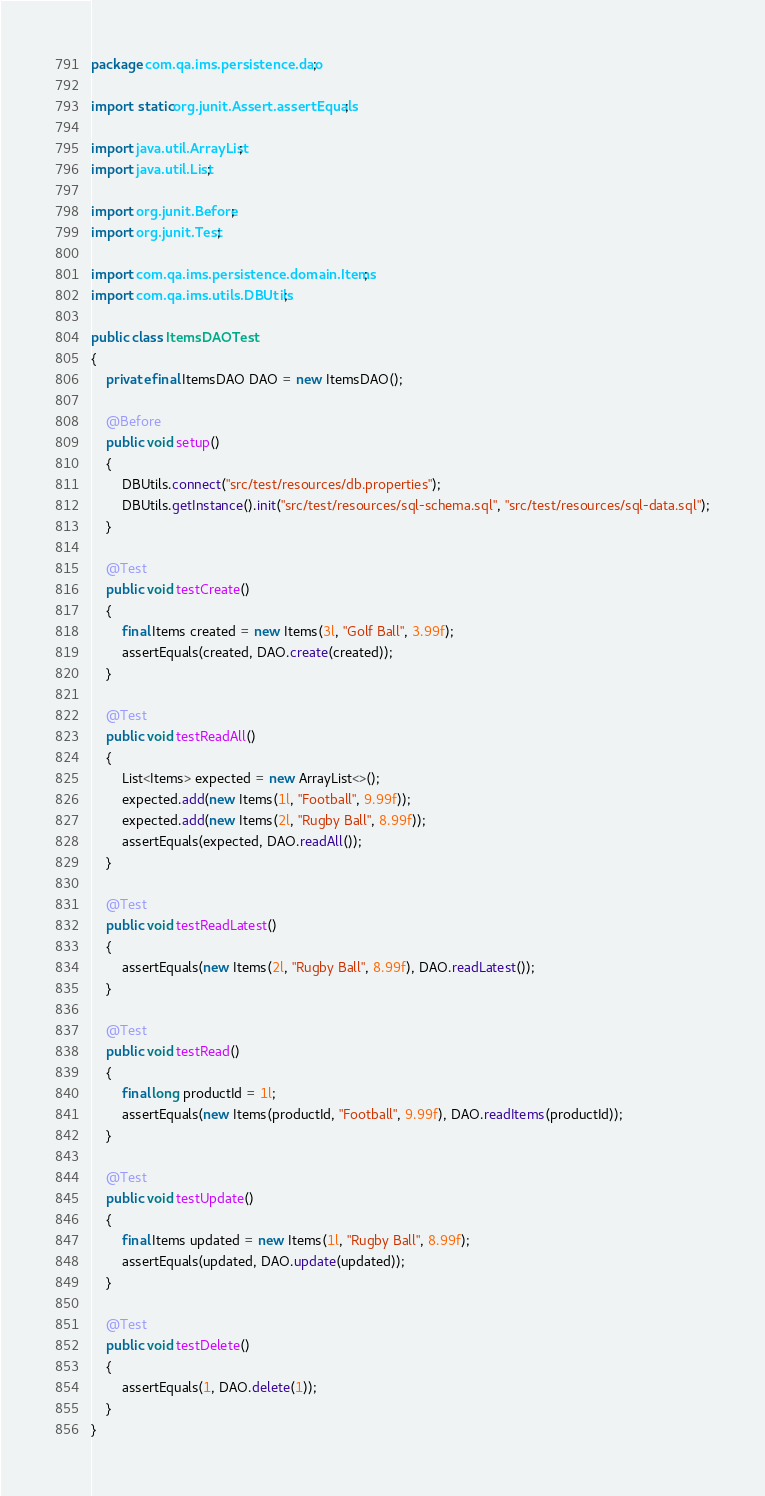<code> <loc_0><loc_0><loc_500><loc_500><_Java_>package com.qa.ims.persistence.dao;

import static org.junit.Assert.assertEquals;

import java.util.ArrayList;
import java.util.List;

import org.junit.Before;
import org.junit.Test;

import com.qa.ims.persistence.domain.Items;
import com.qa.ims.utils.DBUtils;

public class ItemsDAOTest
{
	private final ItemsDAO DAO = new ItemsDAO();

	@Before
	public void setup() 
	{
		DBUtils.connect("src/test/resources/db.properties");
		DBUtils.getInstance().init("src/test/resources/sql-schema.sql", "src/test/resources/sql-data.sql");
	}

	@Test
	public void testCreate() 
	{
		final Items created = new Items(3l, "Golf Ball", 3.99f);
		assertEquals(created, DAO.create(created));
	}

	@Test
	public void testReadAll() 
	{
		List<Items> expected = new ArrayList<>();
		expected.add(new Items(1l, "Football", 9.99f));
		expected.add(new Items(2l, "Rugby Ball", 8.99f));
		assertEquals(expected, DAO.readAll());
	}

	@Test
	public void testReadLatest() 
	{
		assertEquals(new Items(2l, "Rugby Ball", 8.99f), DAO.readLatest());
	}

	@Test
	public void testRead() 
	{
		final long productId = 1l;
		assertEquals(new Items(productId, "Football", 9.99f), DAO.readItems(productId));
	}

	@Test
	public void testUpdate() 
	{
		final Items updated = new Items(1l, "Rugby Ball", 8.99f);
		assertEquals(updated, DAO.update(updated));
	}

	@Test
	public void testDelete() 
	{
		assertEquals(1, DAO.delete(1));
	}
}</code> 